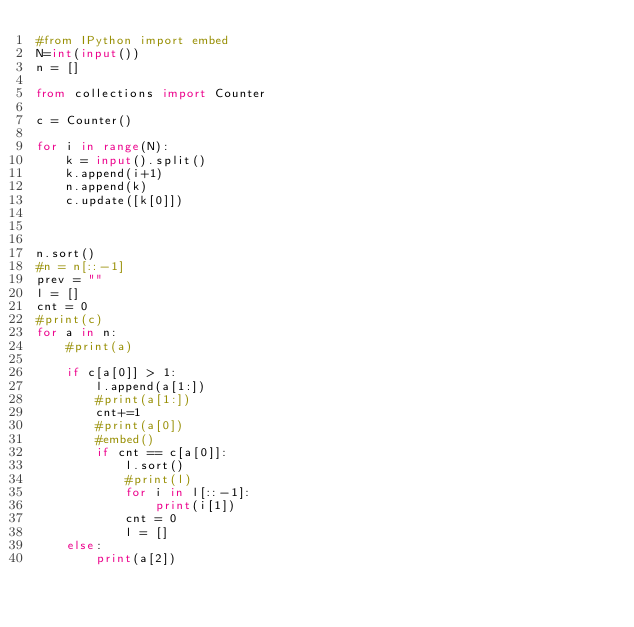<code> <loc_0><loc_0><loc_500><loc_500><_Python_>#from IPython import embed
N=int(input())
n = []

from collections import Counter

c = Counter()

for i in range(N):
    k = input().split()
    k.append(i+1)
    n.append(k)
    c.update([k[0]])



n.sort()
#n = n[::-1]
prev = ""
l = []
cnt = 0
#print(c)
for a in n:
    #print(a)

    if c[a[0]] > 1:
        l.append(a[1:])
        #print(a[1:])
        cnt+=1
        #print(a[0])
        #embed()
        if cnt == c[a[0]]:
            l.sort()
            #print(l)
            for i in l[::-1]:
                print(i[1])
            cnt = 0
            l = []
    else:
        print(a[2])
</code> 